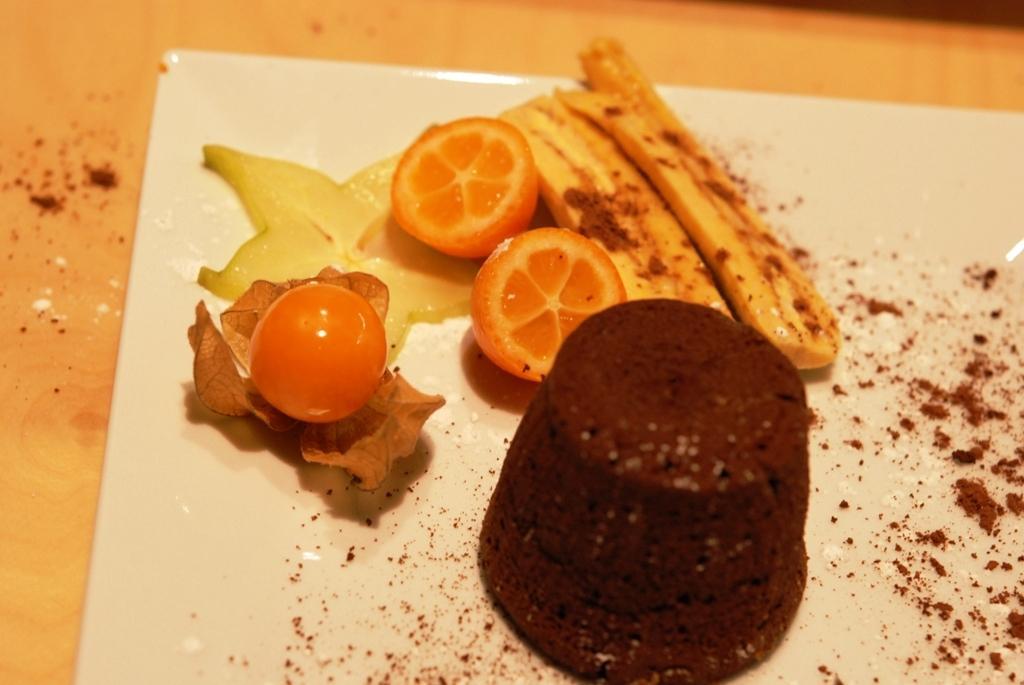Describe this image in one or two sentences. in this image we can see a serving plate which consists of a cake, fruits, leaf and a powder that is sprinkled. 